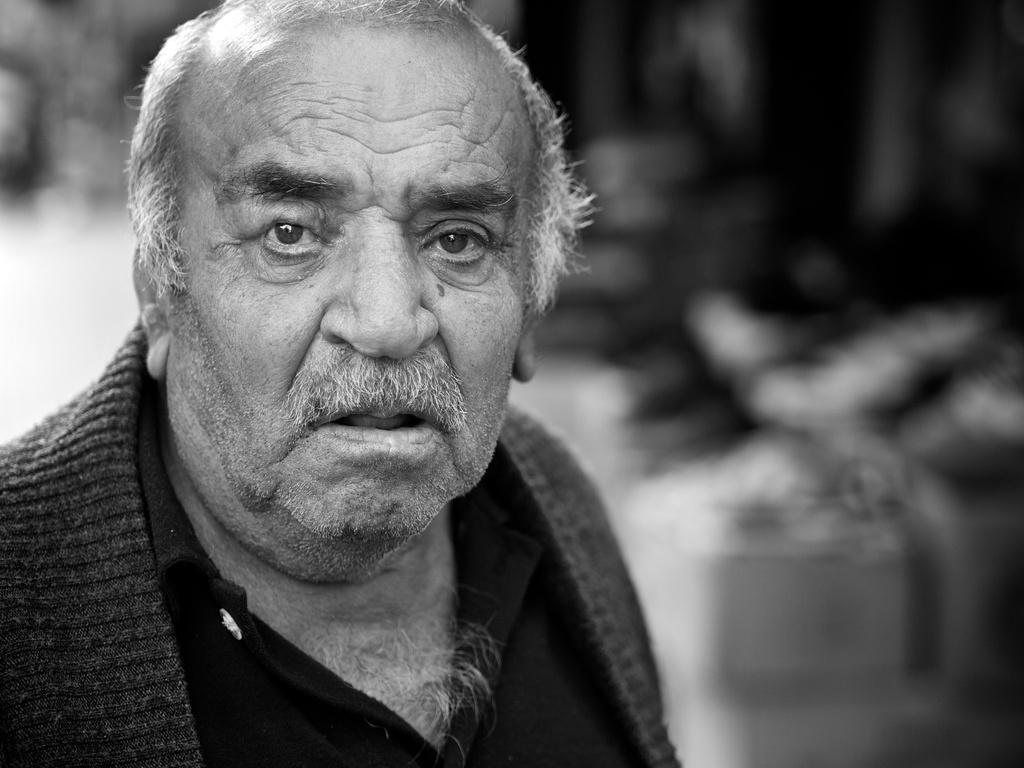Describe this image in one or two sentences. This is a black and white image. I can see an old man in the foreground with a blurred background. 